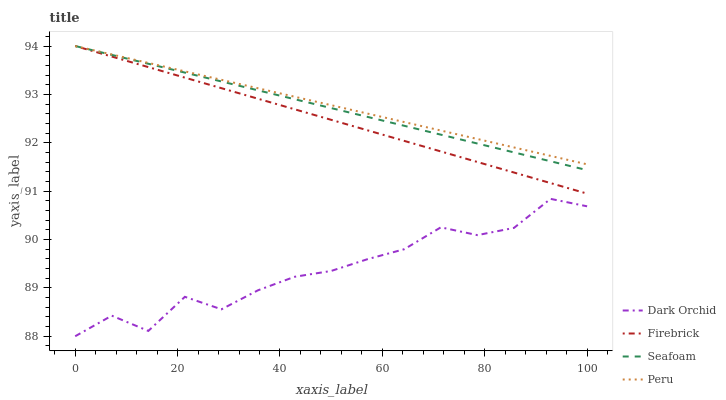Does Firebrick have the minimum area under the curve?
Answer yes or no. No. Does Firebrick have the maximum area under the curve?
Answer yes or no. No. Is Firebrick the smoothest?
Answer yes or no. No. Is Firebrick the roughest?
Answer yes or no. No. Does Firebrick have the lowest value?
Answer yes or no. No. Does Dark Orchid have the highest value?
Answer yes or no. No. Is Dark Orchid less than Peru?
Answer yes or no. Yes. Is Seafoam greater than Dark Orchid?
Answer yes or no. Yes. Does Dark Orchid intersect Peru?
Answer yes or no. No. 